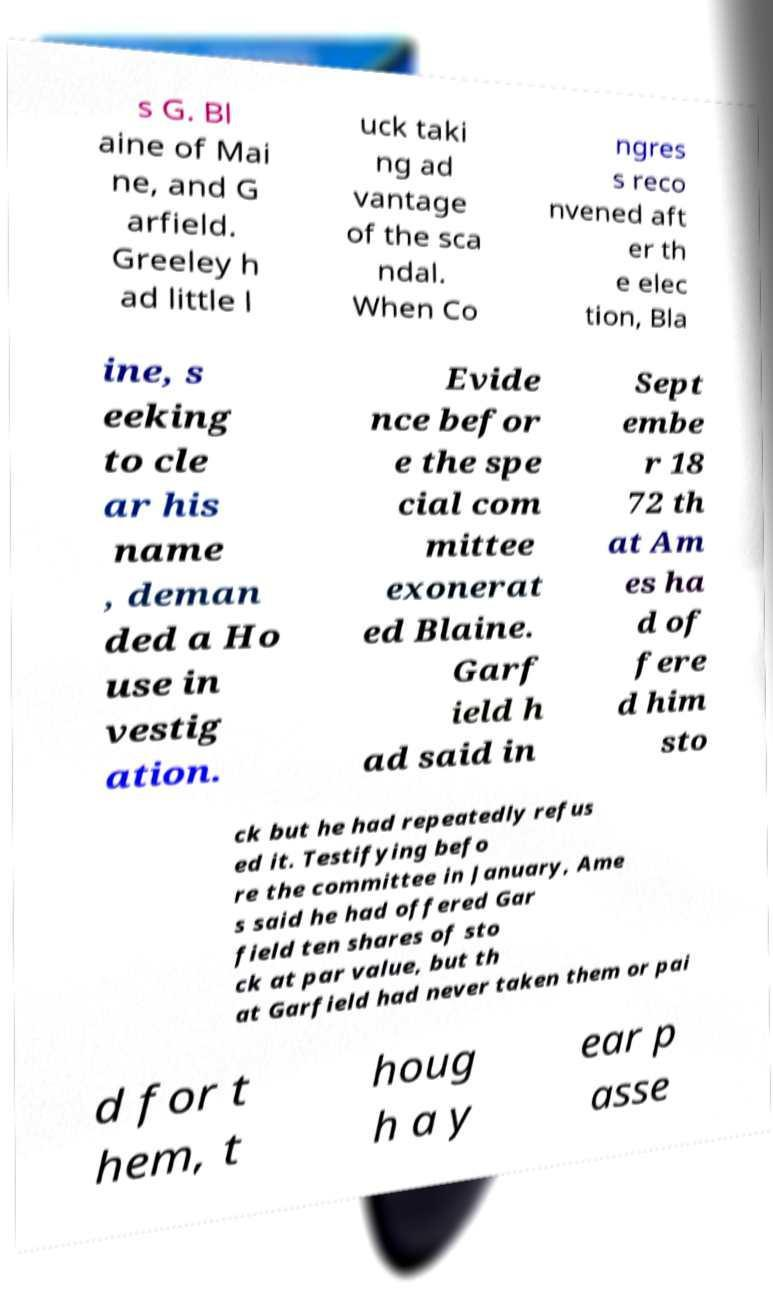There's text embedded in this image that I need extracted. Can you transcribe it verbatim? s G. Bl aine of Mai ne, and G arfield. Greeley h ad little l uck taki ng ad vantage of the sca ndal. When Co ngres s reco nvened aft er th e elec tion, Bla ine, s eeking to cle ar his name , deman ded a Ho use in vestig ation. Evide nce befor e the spe cial com mittee exonerat ed Blaine. Garf ield h ad said in Sept embe r 18 72 th at Am es ha d of fere d him sto ck but he had repeatedly refus ed it. Testifying befo re the committee in January, Ame s said he had offered Gar field ten shares of sto ck at par value, but th at Garfield had never taken them or pai d for t hem, t houg h a y ear p asse 